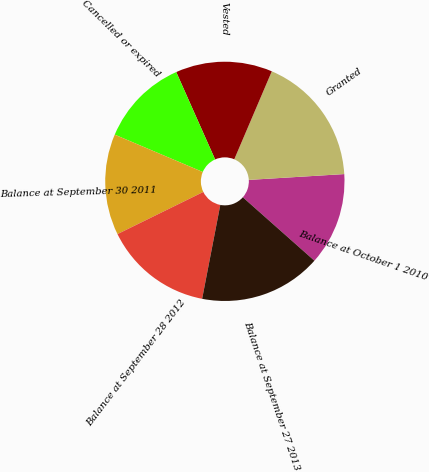<chart> <loc_0><loc_0><loc_500><loc_500><pie_chart><fcel>Balance at October 1 2010<fcel>Granted<fcel>Vested<fcel>Cancelled or expired<fcel>Balance at September 30 2011<fcel>Balance at September 28 2012<fcel>Balance at September 27 2013<nl><fcel>12.51%<fcel>17.61%<fcel>13.08%<fcel>11.95%<fcel>13.65%<fcel>14.69%<fcel>16.5%<nl></chart> 